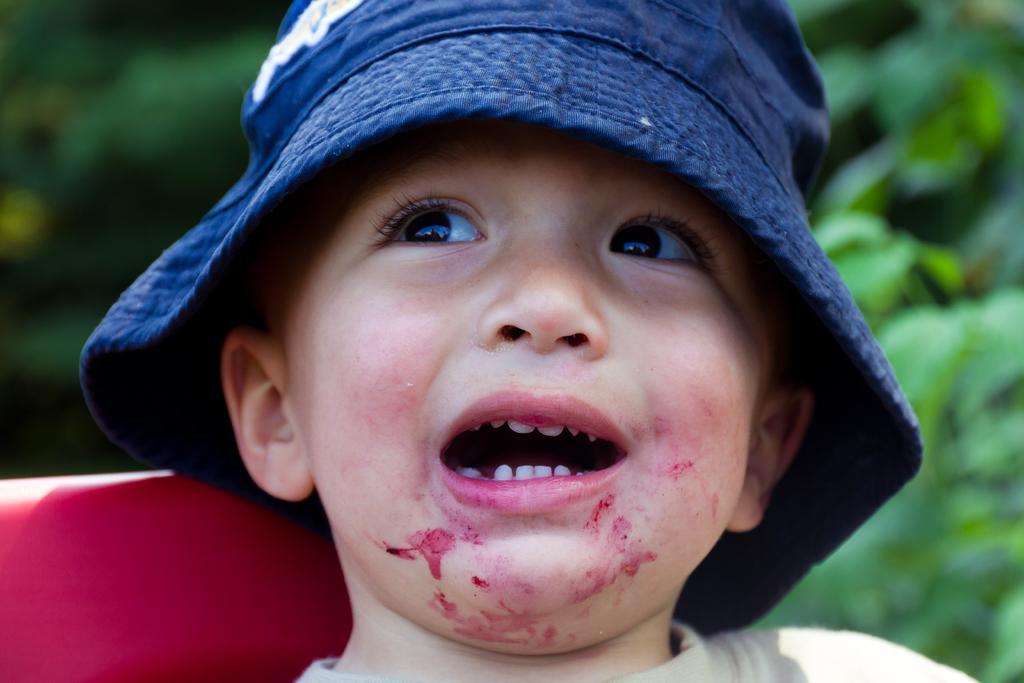In one or two sentences, can you explain what this image depicts? In this image, I can see a boy with a hat. The background looks green in color, which is blurred. It looks like an object. 